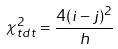Convert formula to latex. <formula><loc_0><loc_0><loc_500><loc_500>\chi _ { t d t } ^ { 2 } = \frac { 4 ( i - j ) ^ { 2 } } { h }</formula> 